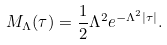<formula> <loc_0><loc_0><loc_500><loc_500>M _ { \Lambda } ( \tau ) = \frac { 1 } { 2 } \Lambda ^ { 2 } e ^ { - \Lambda ^ { 2 } | \tau | } .</formula> 